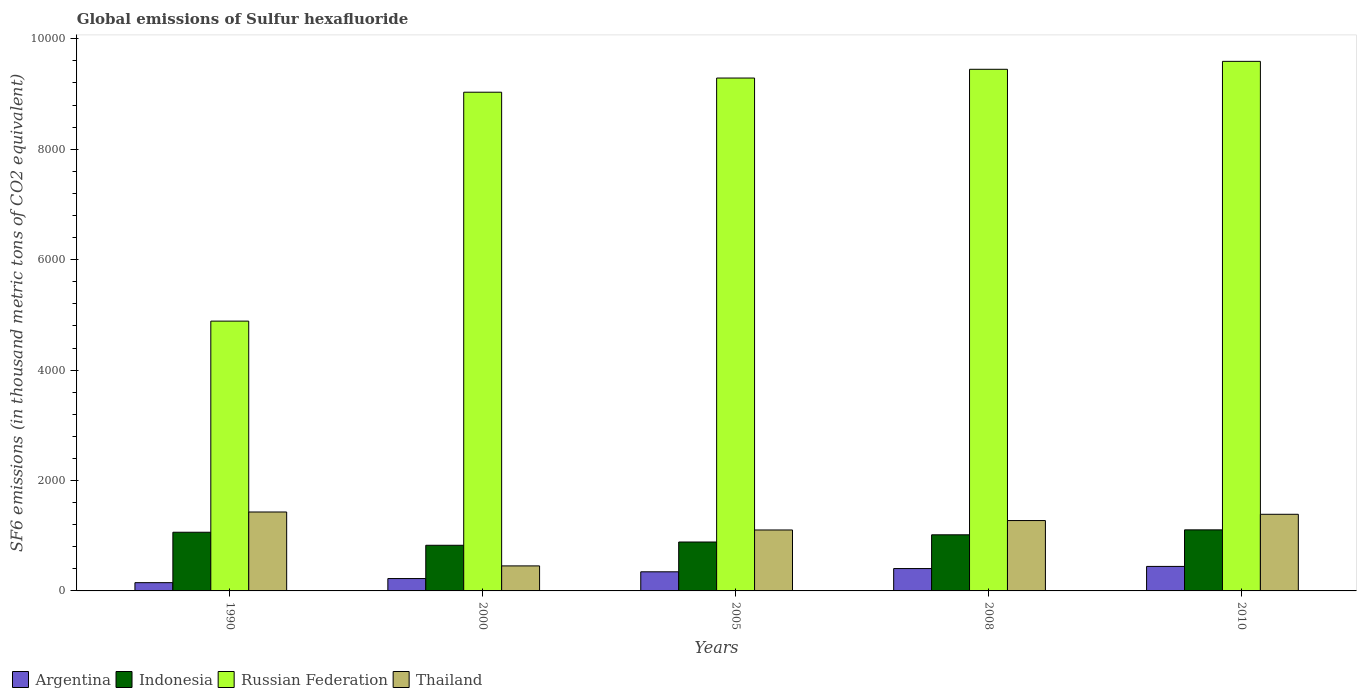How many groups of bars are there?
Your answer should be very brief. 5. Are the number of bars per tick equal to the number of legend labels?
Ensure brevity in your answer.  Yes. Are the number of bars on each tick of the X-axis equal?
Offer a very short reply. Yes. How many bars are there on the 5th tick from the right?
Make the answer very short. 4. What is the label of the 4th group of bars from the left?
Your response must be concise. 2008. In how many cases, is the number of bars for a given year not equal to the number of legend labels?
Offer a terse response. 0. What is the global emissions of Sulfur hexafluoride in Indonesia in 2000?
Your response must be concise. 826.8. Across all years, what is the maximum global emissions of Sulfur hexafluoride in Indonesia?
Give a very brief answer. 1106. Across all years, what is the minimum global emissions of Sulfur hexafluoride in Thailand?
Provide a succinct answer. 453.1. In which year was the global emissions of Sulfur hexafluoride in Thailand maximum?
Your answer should be compact. 1990. In which year was the global emissions of Sulfur hexafluoride in Russian Federation minimum?
Ensure brevity in your answer.  1990. What is the total global emissions of Sulfur hexafluoride in Argentina in the graph?
Make the answer very short. 1568.8. What is the difference between the global emissions of Sulfur hexafluoride in Russian Federation in 1990 and that in 2010?
Your response must be concise. -4705.2. What is the difference between the global emissions of Sulfur hexafluoride in Argentina in 2008 and the global emissions of Sulfur hexafluoride in Russian Federation in 2005?
Make the answer very short. -8884.9. What is the average global emissions of Sulfur hexafluoride in Russian Federation per year?
Your answer should be compact. 8450.02. In the year 2005, what is the difference between the global emissions of Sulfur hexafluoride in Argentina and global emissions of Sulfur hexafluoride in Indonesia?
Ensure brevity in your answer.  -539.9. What is the ratio of the global emissions of Sulfur hexafluoride in Russian Federation in 1990 to that in 2008?
Offer a very short reply. 0.52. Is the difference between the global emissions of Sulfur hexafluoride in Argentina in 1990 and 2000 greater than the difference between the global emissions of Sulfur hexafluoride in Indonesia in 1990 and 2000?
Ensure brevity in your answer.  No. What is the difference between the highest and the second highest global emissions of Sulfur hexafluoride in Thailand?
Your answer should be compact. 41.5. What is the difference between the highest and the lowest global emissions of Sulfur hexafluoride in Indonesia?
Offer a terse response. 279.2. Is the sum of the global emissions of Sulfur hexafluoride in Russian Federation in 1990 and 2010 greater than the maximum global emissions of Sulfur hexafluoride in Indonesia across all years?
Provide a short and direct response. Yes. Is it the case that in every year, the sum of the global emissions of Sulfur hexafluoride in Russian Federation and global emissions of Sulfur hexafluoride in Thailand is greater than the global emissions of Sulfur hexafluoride in Argentina?
Offer a terse response. Yes. How many bars are there?
Provide a succinct answer. 20. How many years are there in the graph?
Ensure brevity in your answer.  5. What is the difference between two consecutive major ticks on the Y-axis?
Provide a short and direct response. 2000. Where does the legend appear in the graph?
Your answer should be compact. Bottom left. How many legend labels are there?
Your response must be concise. 4. How are the legend labels stacked?
Ensure brevity in your answer.  Horizontal. What is the title of the graph?
Provide a succinct answer. Global emissions of Sulfur hexafluoride. Does "Korea (Democratic)" appear as one of the legend labels in the graph?
Your answer should be compact. No. What is the label or title of the X-axis?
Offer a terse response. Years. What is the label or title of the Y-axis?
Your response must be concise. SF6 emissions (in thousand metric tons of CO2 equivalent). What is the SF6 emissions (in thousand metric tons of CO2 equivalent) in Argentina in 1990?
Your response must be concise. 149.6. What is the SF6 emissions (in thousand metric tons of CO2 equivalent) in Indonesia in 1990?
Offer a terse response. 1062.8. What is the SF6 emissions (in thousand metric tons of CO2 equivalent) of Russian Federation in 1990?
Offer a terse response. 4886.8. What is the SF6 emissions (in thousand metric tons of CO2 equivalent) of Thailand in 1990?
Provide a succinct answer. 1429.5. What is the SF6 emissions (in thousand metric tons of CO2 equivalent) in Argentina in 2000?
Provide a short and direct response. 224. What is the SF6 emissions (in thousand metric tons of CO2 equivalent) of Indonesia in 2000?
Give a very brief answer. 826.8. What is the SF6 emissions (in thousand metric tons of CO2 equivalent) of Russian Federation in 2000?
Your answer should be very brief. 9033.2. What is the SF6 emissions (in thousand metric tons of CO2 equivalent) of Thailand in 2000?
Provide a succinct answer. 453.1. What is the SF6 emissions (in thousand metric tons of CO2 equivalent) in Argentina in 2005?
Provide a succinct answer. 346.2. What is the SF6 emissions (in thousand metric tons of CO2 equivalent) of Indonesia in 2005?
Your answer should be very brief. 886.1. What is the SF6 emissions (in thousand metric tons of CO2 equivalent) in Russian Federation in 2005?
Make the answer very short. 9289.9. What is the SF6 emissions (in thousand metric tons of CO2 equivalent) in Thailand in 2005?
Your response must be concise. 1103.9. What is the SF6 emissions (in thousand metric tons of CO2 equivalent) of Argentina in 2008?
Ensure brevity in your answer.  405. What is the SF6 emissions (in thousand metric tons of CO2 equivalent) of Indonesia in 2008?
Give a very brief answer. 1016.4. What is the SF6 emissions (in thousand metric tons of CO2 equivalent) in Russian Federation in 2008?
Your answer should be compact. 9448.2. What is the SF6 emissions (in thousand metric tons of CO2 equivalent) in Thailand in 2008?
Your answer should be compact. 1274.5. What is the SF6 emissions (in thousand metric tons of CO2 equivalent) of Argentina in 2010?
Your response must be concise. 444. What is the SF6 emissions (in thousand metric tons of CO2 equivalent) of Indonesia in 2010?
Make the answer very short. 1106. What is the SF6 emissions (in thousand metric tons of CO2 equivalent) in Russian Federation in 2010?
Offer a terse response. 9592. What is the SF6 emissions (in thousand metric tons of CO2 equivalent) of Thailand in 2010?
Your answer should be compact. 1388. Across all years, what is the maximum SF6 emissions (in thousand metric tons of CO2 equivalent) in Argentina?
Your answer should be very brief. 444. Across all years, what is the maximum SF6 emissions (in thousand metric tons of CO2 equivalent) of Indonesia?
Provide a short and direct response. 1106. Across all years, what is the maximum SF6 emissions (in thousand metric tons of CO2 equivalent) in Russian Federation?
Your response must be concise. 9592. Across all years, what is the maximum SF6 emissions (in thousand metric tons of CO2 equivalent) of Thailand?
Give a very brief answer. 1429.5. Across all years, what is the minimum SF6 emissions (in thousand metric tons of CO2 equivalent) in Argentina?
Keep it short and to the point. 149.6. Across all years, what is the minimum SF6 emissions (in thousand metric tons of CO2 equivalent) in Indonesia?
Provide a short and direct response. 826.8. Across all years, what is the minimum SF6 emissions (in thousand metric tons of CO2 equivalent) in Russian Federation?
Make the answer very short. 4886.8. Across all years, what is the minimum SF6 emissions (in thousand metric tons of CO2 equivalent) of Thailand?
Make the answer very short. 453.1. What is the total SF6 emissions (in thousand metric tons of CO2 equivalent) of Argentina in the graph?
Offer a terse response. 1568.8. What is the total SF6 emissions (in thousand metric tons of CO2 equivalent) of Indonesia in the graph?
Your answer should be compact. 4898.1. What is the total SF6 emissions (in thousand metric tons of CO2 equivalent) in Russian Federation in the graph?
Provide a short and direct response. 4.23e+04. What is the total SF6 emissions (in thousand metric tons of CO2 equivalent) in Thailand in the graph?
Give a very brief answer. 5649. What is the difference between the SF6 emissions (in thousand metric tons of CO2 equivalent) of Argentina in 1990 and that in 2000?
Give a very brief answer. -74.4. What is the difference between the SF6 emissions (in thousand metric tons of CO2 equivalent) of Indonesia in 1990 and that in 2000?
Ensure brevity in your answer.  236. What is the difference between the SF6 emissions (in thousand metric tons of CO2 equivalent) in Russian Federation in 1990 and that in 2000?
Provide a short and direct response. -4146.4. What is the difference between the SF6 emissions (in thousand metric tons of CO2 equivalent) in Thailand in 1990 and that in 2000?
Provide a short and direct response. 976.4. What is the difference between the SF6 emissions (in thousand metric tons of CO2 equivalent) of Argentina in 1990 and that in 2005?
Ensure brevity in your answer.  -196.6. What is the difference between the SF6 emissions (in thousand metric tons of CO2 equivalent) of Indonesia in 1990 and that in 2005?
Provide a succinct answer. 176.7. What is the difference between the SF6 emissions (in thousand metric tons of CO2 equivalent) of Russian Federation in 1990 and that in 2005?
Provide a succinct answer. -4403.1. What is the difference between the SF6 emissions (in thousand metric tons of CO2 equivalent) in Thailand in 1990 and that in 2005?
Provide a short and direct response. 325.6. What is the difference between the SF6 emissions (in thousand metric tons of CO2 equivalent) of Argentina in 1990 and that in 2008?
Give a very brief answer. -255.4. What is the difference between the SF6 emissions (in thousand metric tons of CO2 equivalent) of Indonesia in 1990 and that in 2008?
Your answer should be very brief. 46.4. What is the difference between the SF6 emissions (in thousand metric tons of CO2 equivalent) of Russian Federation in 1990 and that in 2008?
Your answer should be compact. -4561.4. What is the difference between the SF6 emissions (in thousand metric tons of CO2 equivalent) of Thailand in 1990 and that in 2008?
Your answer should be very brief. 155. What is the difference between the SF6 emissions (in thousand metric tons of CO2 equivalent) of Argentina in 1990 and that in 2010?
Offer a terse response. -294.4. What is the difference between the SF6 emissions (in thousand metric tons of CO2 equivalent) in Indonesia in 1990 and that in 2010?
Provide a short and direct response. -43.2. What is the difference between the SF6 emissions (in thousand metric tons of CO2 equivalent) in Russian Federation in 1990 and that in 2010?
Provide a short and direct response. -4705.2. What is the difference between the SF6 emissions (in thousand metric tons of CO2 equivalent) in Thailand in 1990 and that in 2010?
Your answer should be compact. 41.5. What is the difference between the SF6 emissions (in thousand metric tons of CO2 equivalent) of Argentina in 2000 and that in 2005?
Your answer should be compact. -122.2. What is the difference between the SF6 emissions (in thousand metric tons of CO2 equivalent) in Indonesia in 2000 and that in 2005?
Give a very brief answer. -59.3. What is the difference between the SF6 emissions (in thousand metric tons of CO2 equivalent) of Russian Federation in 2000 and that in 2005?
Offer a very short reply. -256.7. What is the difference between the SF6 emissions (in thousand metric tons of CO2 equivalent) of Thailand in 2000 and that in 2005?
Your answer should be very brief. -650.8. What is the difference between the SF6 emissions (in thousand metric tons of CO2 equivalent) of Argentina in 2000 and that in 2008?
Make the answer very short. -181. What is the difference between the SF6 emissions (in thousand metric tons of CO2 equivalent) in Indonesia in 2000 and that in 2008?
Make the answer very short. -189.6. What is the difference between the SF6 emissions (in thousand metric tons of CO2 equivalent) of Russian Federation in 2000 and that in 2008?
Make the answer very short. -415. What is the difference between the SF6 emissions (in thousand metric tons of CO2 equivalent) in Thailand in 2000 and that in 2008?
Offer a terse response. -821.4. What is the difference between the SF6 emissions (in thousand metric tons of CO2 equivalent) in Argentina in 2000 and that in 2010?
Offer a terse response. -220. What is the difference between the SF6 emissions (in thousand metric tons of CO2 equivalent) of Indonesia in 2000 and that in 2010?
Provide a succinct answer. -279.2. What is the difference between the SF6 emissions (in thousand metric tons of CO2 equivalent) of Russian Federation in 2000 and that in 2010?
Give a very brief answer. -558.8. What is the difference between the SF6 emissions (in thousand metric tons of CO2 equivalent) of Thailand in 2000 and that in 2010?
Keep it short and to the point. -934.9. What is the difference between the SF6 emissions (in thousand metric tons of CO2 equivalent) in Argentina in 2005 and that in 2008?
Make the answer very short. -58.8. What is the difference between the SF6 emissions (in thousand metric tons of CO2 equivalent) of Indonesia in 2005 and that in 2008?
Provide a short and direct response. -130.3. What is the difference between the SF6 emissions (in thousand metric tons of CO2 equivalent) in Russian Federation in 2005 and that in 2008?
Provide a succinct answer. -158.3. What is the difference between the SF6 emissions (in thousand metric tons of CO2 equivalent) in Thailand in 2005 and that in 2008?
Make the answer very short. -170.6. What is the difference between the SF6 emissions (in thousand metric tons of CO2 equivalent) of Argentina in 2005 and that in 2010?
Keep it short and to the point. -97.8. What is the difference between the SF6 emissions (in thousand metric tons of CO2 equivalent) of Indonesia in 2005 and that in 2010?
Your answer should be compact. -219.9. What is the difference between the SF6 emissions (in thousand metric tons of CO2 equivalent) in Russian Federation in 2005 and that in 2010?
Your answer should be very brief. -302.1. What is the difference between the SF6 emissions (in thousand metric tons of CO2 equivalent) of Thailand in 2005 and that in 2010?
Make the answer very short. -284.1. What is the difference between the SF6 emissions (in thousand metric tons of CO2 equivalent) in Argentina in 2008 and that in 2010?
Provide a short and direct response. -39. What is the difference between the SF6 emissions (in thousand metric tons of CO2 equivalent) of Indonesia in 2008 and that in 2010?
Your answer should be very brief. -89.6. What is the difference between the SF6 emissions (in thousand metric tons of CO2 equivalent) in Russian Federation in 2008 and that in 2010?
Your answer should be very brief. -143.8. What is the difference between the SF6 emissions (in thousand metric tons of CO2 equivalent) of Thailand in 2008 and that in 2010?
Offer a very short reply. -113.5. What is the difference between the SF6 emissions (in thousand metric tons of CO2 equivalent) in Argentina in 1990 and the SF6 emissions (in thousand metric tons of CO2 equivalent) in Indonesia in 2000?
Offer a very short reply. -677.2. What is the difference between the SF6 emissions (in thousand metric tons of CO2 equivalent) in Argentina in 1990 and the SF6 emissions (in thousand metric tons of CO2 equivalent) in Russian Federation in 2000?
Make the answer very short. -8883.6. What is the difference between the SF6 emissions (in thousand metric tons of CO2 equivalent) of Argentina in 1990 and the SF6 emissions (in thousand metric tons of CO2 equivalent) of Thailand in 2000?
Keep it short and to the point. -303.5. What is the difference between the SF6 emissions (in thousand metric tons of CO2 equivalent) in Indonesia in 1990 and the SF6 emissions (in thousand metric tons of CO2 equivalent) in Russian Federation in 2000?
Offer a terse response. -7970.4. What is the difference between the SF6 emissions (in thousand metric tons of CO2 equivalent) in Indonesia in 1990 and the SF6 emissions (in thousand metric tons of CO2 equivalent) in Thailand in 2000?
Your answer should be compact. 609.7. What is the difference between the SF6 emissions (in thousand metric tons of CO2 equivalent) in Russian Federation in 1990 and the SF6 emissions (in thousand metric tons of CO2 equivalent) in Thailand in 2000?
Provide a short and direct response. 4433.7. What is the difference between the SF6 emissions (in thousand metric tons of CO2 equivalent) of Argentina in 1990 and the SF6 emissions (in thousand metric tons of CO2 equivalent) of Indonesia in 2005?
Keep it short and to the point. -736.5. What is the difference between the SF6 emissions (in thousand metric tons of CO2 equivalent) in Argentina in 1990 and the SF6 emissions (in thousand metric tons of CO2 equivalent) in Russian Federation in 2005?
Offer a very short reply. -9140.3. What is the difference between the SF6 emissions (in thousand metric tons of CO2 equivalent) of Argentina in 1990 and the SF6 emissions (in thousand metric tons of CO2 equivalent) of Thailand in 2005?
Make the answer very short. -954.3. What is the difference between the SF6 emissions (in thousand metric tons of CO2 equivalent) in Indonesia in 1990 and the SF6 emissions (in thousand metric tons of CO2 equivalent) in Russian Federation in 2005?
Your response must be concise. -8227.1. What is the difference between the SF6 emissions (in thousand metric tons of CO2 equivalent) of Indonesia in 1990 and the SF6 emissions (in thousand metric tons of CO2 equivalent) of Thailand in 2005?
Provide a succinct answer. -41.1. What is the difference between the SF6 emissions (in thousand metric tons of CO2 equivalent) in Russian Federation in 1990 and the SF6 emissions (in thousand metric tons of CO2 equivalent) in Thailand in 2005?
Keep it short and to the point. 3782.9. What is the difference between the SF6 emissions (in thousand metric tons of CO2 equivalent) of Argentina in 1990 and the SF6 emissions (in thousand metric tons of CO2 equivalent) of Indonesia in 2008?
Offer a terse response. -866.8. What is the difference between the SF6 emissions (in thousand metric tons of CO2 equivalent) in Argentina in 1990 and the SF6 emissions (in thousand metric tons of CO2 equivalent) in Russian Federation in 2008?
Provide a short and direct response. -9298.6. What is the difference between the SF6 emissions (in thousand metric tons of CO2 equivalent) in Argentina in 1990 and the SF6 emissions (in thousand metric tons of CO2 equivalent) in Thailand in 2008?
Make the answer very short. -1124.9. What is the difference between the SF6 emissions (in thousand metric tons of CO2 equivalent) of Indonesia in 1990 and the SF6 emissions (in thousand metric tons of CO2 equivalent) of Russian Federation in 2008?
Provide a succinct answer. -8385.4. What is the difference between the SF6 emissions (in thousand metric tons of CO2 equivalent) in Indonesia in 1990 and the SF6 emissions (in thousand metric tons of CO2 equivalent) in Thailand in 2008?
Ensure brevity in your answer.  -211.7. What is the difference between the SF6 emissions (in thousand metric tons of CO2 equivalent) in Russian Federation in 1990 and the SF6 emissions (in thousand metric tons of CO2 equivalent) in Thailand in 2008?
Offer a very short reply. 3612.3. What is the difference between the SF6 emissions (in thousand metric tons of CO2 equivalent) in Argentina in 1990 and the SF6 emissions (in thousand metric tons of CO2 equivalent) in Indonesia in 2010?
Offer a very short reply. -956.4. What is the difference between the SF6 emissions (in thousand metric tons of CO2 equivalent) of Argentina in 1990 and the SF6 emissions (in thousand metric tons of CO2 equivalent) of Russian Federation in 2010?
Provide a succinct answer. -9442.4. What is the difference between the SF6 emissions (in thousand metric tons of CO2 equivalent) of Argentina in 1990 and the SF6 emissions (in thousand metric tons of CO2 equivalent) of Thailand in 2010?
Offer a very short reply. -1238.4. What is the difference between the SF6 emissions (in thousand metric tons of CO2 equivalent) of Indonesia in 1990 and the SF6 emissions (in thousand metric tons of CO2 equivalent) of Russian Federation in 2010?
Offer a terse response. -8529.2. What is the difference between the SF6 emissions (in thousand metric tons of CO2 equivalent) in Indonesia in 1990 and the SF6 emissions (in thousand metric tons of CO2 equivalent) in Thailand in 2010?
Ensure brevity in your answer.  -325.2. What is the difference between the SF6 emissions (in thousand metric tons of CO2 equivalent) in Russian Federation in 1990 and the SF6 emissions (in thousand metric tons of CO2 equivalent) in Thailand in 2010?
Provide a short and direct response. 3498.8. What is the difference between the SF6 emissions (in thousand metric tons of CO2 equivalent) in Argentina in 2000 and the SF6 emissions (in thousand metric tons of CO2 equivalent) in Indonesia in 2005?
Your answer should be compact. -662.1. What is the difference between the SF6 emissions (in thousand metric tons of CO2 equivalent) of Argentina in 2000 and the SF6 emissions (in thousand metric tons of CO2 equivalent) of Russian Federation in 2005?
Your answer should be very brief. -9065.9. What is the difference between the SF6 emissions (in thousand metric tons of CO2 equivalent) of Argentina in 2000 and the SF6 emissions (in thousand metric tons of CO2 equivalent) of Thailand in 2005?
Offer a very short reply. -879.9. What is the difference between the SF6 emissions (in thousand metric tons of CO2 equivalent) of Indonesia in 2000 and the SF6 emissions (in thousand metric tons of CO2 equivalent) of Russian Federation in 2005?
Ensure brevity in your answer.  -8463.1. What is the difference between the SF6 emissions (in thousand metric tons of CO2 equivalent) of Indonesia in 2000 and the SF6 emissions (in thousand metric tons of CO2 equivalent) of Thailand in 2005?
Offer a terse response. -277.1. What is the difference between the SF6 emissions (in thousand metric tons of CO2 equivalent) in Russian Federation in 2000 and the SF6 emissions (in thousand metric tons of CO2 equivalent) in Thailand in 2005?
Keep it short and to the point. 7929.3. What is the difference between the SF6 emissions (in thousand metric tons of CO2 equivalent) of Argentina in 2000 and the SF6 emissions (in thousand metric tons of CO2 equivalent) of Indonesia in 2008?
Your answer should be compact. -792.4. What is the difference between the SF6 emissions (in thousand metric tons of CO2 equivalent) in Argentina in 2000 and the SF6 emissions (in thousand metric tons of CO2 equivalent) in Russian Federation in 2008?
Provide a short and direct response. -9224.2. What is the difference between the SF6 emissions (in thousand metric tons of CO2 equivalent) in Argentina in 2000 and the SF6 emissions (in thousand metric tons of CO2 equivalent) in Thailand in 2008?
Provide a short and direct response. -1050.5. What is the difference between the SF6 emissions (in thousand metric tons of CO2 equivalent) of Indonesia in 2000 and the SF6 emissions (in thousand metric tons of CO2 equivalent) of Russian Federation in 2008?
Your response must be concise. -8621.4. What is the difference between the SF6 emissions (in thousand metric tons of CO2 equivalent) in Indonesia in 2000 and the SF6 emissions (in thousand metric tons of CO2 equivalent) in Thailand in 2008?
Offer a very short reply. -447.7. What is the difference between the SF6 emissions (in thousand metric tons of CO2 equivalent) of Russian Federation in 2000 and the SF6 emissions (in thousand metric tons of CO2 equivalent) of Thailand in 2008?
Your answer should be compact. 7758.7. What is the difference between the SF6 emissions (in thousand metric tons of CO2 equivalent) of Argentina in 2000 and the SF6 emissions (in thousand metric tons of CO2 equivalent) of Indonesia in 2010?
Make the answer very short. -882. What is the difference between the SF6 emissions (in thousand metric tons of CO2 equivalent) in Argentina in 2000 and the SF6 emissions (in thousand metric tons of CO2 equivalent) in Russian Federation in 2010?
Your answer should be very brief. -9368. What is the difference between the SF6 emissions (in thousand metric tons of CO2 equivalent) of Argentina in 2000 and the SF6 emissions (in thousand metric tons of CO2 equivalent) of Thailand in 2010?
Ensure brevity in your answer.  -1164. What is the difference between the SF6 emissions (in thousand metric tons of CO2 equivalent) of Indonesia in 2000 and the SF6 emissions (in thousand metric tons of CO2 equivalent) of Russian Federation in 2010?
Ensure brevity in your answer.  -8765.2. What is the difference between the SF6 emissions (in thousand metric tons of CO2 equivalent) in Indonesia in 2000 and the SF6 emissions (in thousand metric tons of CO2 equivalent) in Thailand in 2010?
Your answer should be very brief. -561.2. What is the difference between the SF6 emissions (in thousand metric tons of CO2 equivalent) of Russian Federation in 2000 and the SF6 emissions (in thousand metric tons of CO2 equivalent) of Thailand in 2010?
Provide a short and direct response. 7645.2. What is the difference between the SF6 emissions (in thousand metric tons of CO2 equivalent) in Argentina in 2005 and the SF6 emissions (in thousand metric tons of CO2 equivalent) in Indonesia in 2008?
Provide a short and direct response. -670.2. What is the difference between the SF6 emissions (in thousand metric tons of CO2 equivalent) in Argentina in 2005 and the SF6 emissions (in thousand metric tons of CO2 equivalent) in Russian Federation in 2008?
Your answer should be very brief. -9102. What is the difference between the SF6 emissions (in thousand metric tons of CO2 equivalent) of Argentina in 2005 and the SF6 emissions (in thousand metric tons of CO2 equivalent) of Thailand in 2008?
Provide a short and direct response. -928.3. What is the difference between the SF6 emissions (in thousand metric tons of CO2 equivalent) in Indonesia in 2005 and the SF6 emissions (in thousand metric tons of CO2 equivalent) in Russian Federation in 2008?
Your answer should be very brief. -8562.1. What is the difference between the SF6 emissions (in thousand metric tons of CO2 equivalent) in Indonesia in 2005 and the SF6 emissions (in thousand metric tons of CO2 equivalent) in Thailand in 2008?
Give a very brief answer. -388.4. What is the difference between the SF6 emissions (in thousand metric tons of CO2 equivalent) of Russian Federation in 2005 and the SF6 emissions (in thousand metric tons of CO2 equivalent) of Thailand in 2008?
Ensure brevity in your answer.  8015.4. What is the difference between the SF6 emissions (in thousand metric tons of CO2 equivalent) of Argentina in 2005 and the SF6 emissions (in thousand metric tons of CO2 equivalent) of Indonesia in 2010?
Your answer should be very brief. -759.8. What is the difference between the SF6 emissions (in thousand metric tons of CO2 equivalent) in Argentina in 2005 and the SF6 emissions (in thousand metric tons of CO2 equivalent) in Russian Federation in 2010?
Your answer should be very brief. -9245.8. What is the difference between the SF6 emissions (in thousand metric tons of CO2 equivalent) of Argentina in 2005 and the SF6 emissions (in thousand metric tons of CO2 equivalent) of Thailand in 2010?
Ensure brevity in your answer.  -1041.8. What is the difference between the SF6 emissions (in thousand metric tons of CO2 equivalent) of Indonesia in 2005 and the SF6 emissions (in thousand metric tons of CO2 equivalent) of Russian Federation in 2010?
Offer a very short reply. -8705.9. What is the difference between the SF6 emissions (in thousand metric tons of CO2 equivalent) of Indonesia in 2005 and the SF6 emissions (in thousand metric tons of CO2 equivalent) of Thailand in 2010?
Keep it short and to the point. -501.9. What is the difference between the SF6 emissions (in thousand metric tons of CO2 equivalent) in Russian Federation in 2005 and the SF6 emissions (in thousand metric tons of CO2 equivalent) in Thailand in 2010?
Ensure brevity in your answer.  7901.9. What is the difference between the SF6 emissions (in thousand metric tons of CO2 equivalent) of Argentina in 2008 and the SF6 emissions (in thousand metric tons of CO2 equivalent) of Indonesia in 2010?
Your answer should be compact. -701. What is the difference between the SF6 emissions (in thousand metric tons of CO2 equivalent) of Argentina in 2008 and the SF6 emissions (in thousand metric tons of CO2 equivalent) of Russian Federation in 2010?
Keep it short and to the point. -9187. What is the difference between the SF6 emissions (in thousand metric tons of CO2 equivalent) in Argentina in 2008 and the SF6 emissions (in thousand metric tons of CO2 equivalent) in Thailand in 2010?
Make the answer very short. -983. What is the difference between the SF6 emissions (in thousand metric tons of CO2 equivalent) of Indonesia in 2008 and the SF6 emissions (in thousand metric tons of CO2 equivalent) of Russian Federation in 2010?
Provide a short and direct response. -8575.6. What is the difference between the SF6 emissions (in thousand metric tons of CO2 equivalent) in Indonesia in 2008 and the SF6 emissions (in thousand metric tons of CO2 equivalent) in Thailand in 2010?
Offer a very short reply. -371.6. What is the difference between the SF6 emissions (in thousand metric tons of CO2 equivalent) in Russian Federation in 2008 and the SF6 emissions (in thousand metric tons of CO2 equivalent) in Thailand in 2010?
Provide a succinct answer. 8060.2. What is the average SF6 emissions (in thousand metric tons of CO2 equivalent) in Argentina per year?
Your response must be concise. 313.76. What is the average SF6 emissions (in thousand metric tons of CO2 equivalent) in Indonesia per year?
Provide a succinct answer. 979.62. What is the average SF6 emissions (in thousand metric tons of CO2 equivalent) of Russian Federation per year?
Your answer should be very brief. 8450.02. What is the average SF6 emissions (in thousand metric tons of CO2 equivalent) in Thailand per year?
Keep it short and to the point. 1129.8. In the year 1990, what is the difference between the SF6 emissions (in thousand metric tons of CO2 equivalent) in Argentina and SF6 emissions (in thousand metric tons of CO2 equivalent) in Indonesia?
Your answer should be very brief. -913.2. In the year 1990, what is the difference between the SF6 emissions (in thousand metric tons of CO2 equivalent) of Argentina and SF6 emissions (in thousand metric tons of CO2 equivalent) of Russian Federation?
Your response must be concise. -4737.2. In the year 1990, what is the difference between the SF6 emissions (in thousand metric tons of CO2 equivalent) of Argentina and SF6 emissions (in thousand metric tons of CO2 equivalent) of Thailand?
Give a very brief answer. -1279.9. In the year 1990, what is the difference between the SF6 emissions (in thousand metric tons of CO2 equivalent) of Indonesia and SF6 emissions (in thousand metric tons of CO2 equivalent) of Russian Federation?
Your response must be concise. -3824. In the year 1990, what is the difference between the SF6 emissions (in thousand metric tons of CO2 equivalent) in Indonesia and SF6 emissions (in thousand metric tons of CO2 equivalent) in Thailand?
Offer a very short reply. -366.7. In the year 1990, what is the difference between the SF6 emissions (in thousand metric tons of CO2 equivalent) in Russian Federation and SF6 emissions (in thousand metric tons of CO2 equivalent) in Thailand?
Give a very brief answer. 3457.3. In the year 2000, what is the difference between the SF6 emissions (in thousand metric tons of CO2 equivalent) of Argentina and SF6 emissions (in thousand metric tons of CO2 equivalent) of Indonesia?
Your answer should be compact. -602.8. In the year 2000, what is the difference between the SF6 emissions (in thousand metric tons of CO2 equivalent) of Argentina and SF6 emissions (in thousand metric tons of CO2 equivalent) of Russian Federation?
Your answer should be very brief. -8809.2. In the year 2000, what is the difference between the SF6 emissions (in thousand metric tons of CO2 equivalent) of Argentina and SF6 emissions (in thousand metric tons of CO2 equivalent) of Thailand?
Provide a succinct answer. -229.1. In the year 2000, what is the difference between the SF6 emissions (in thousand metric tons of CO2 equivalent) in Indonesia and SF6 emissions (in thousand metric tons of CO2 equivalent) in Russian Federation?
Offer a terse response. -8206.4. In the year 2000, what is the difference between the SF6 emissions (in thousand metric tons of CO2 equivalent) in Indonesia and SF6 emissions (in thousand metric tons of CO2 equivalent) in Thailand?
Keep it short and to the point. 373.7. In the year 2000, what is the difference between the SF6 emissions (in thousand metric tons of CO2 equivalent) in Russian Federation and SF6 emissions (in thousand metric tons of CO2 equivalent) in Thailand?
Your answer should be very brief. 8580.1. In the year 2005, what is the difference between the SF6 emissions (in thousand metric tons of CO2 equivalent) in Argentina and SF6 emissions (in thousand metric tons of CO2 equivalent) in Indonesia?
Your answer should be compact. -539.9. In the year 2005, what is the difference between the SF6 emissions (in thousand metric tons of CO2 equivalent) of Argentina and SF6 emissions (in thousand metric tons of CO2 equivalent) of Russian Federation?
Your response must be concise. -8943.7. In the year 2005, what is the difference between the SF6 emissions (in thousand metric tons of CO2 equivalent) in Argentina and SF6 emissions (in thousand metric tons of CO2 equivalent) in Thailand?
Make the answer very short. -757.7. In the year 2005, what is the difference between the SF6 emissions (in thousand metric tons of CO2 equivalent) of Indonesia and SF6 emissions (in thousand metric tons of CO2 equivalent) of Russian Federation?
Provide a succinct answer. -8403.8. In the year 2005, what is the difference between the SF6 emissions (in thousand metric tons of CO2 equivalent) of Indonesia and SF6 emissions (in thousand metric tons of CO2 equivalent) of Thailand?
Your response must be concise. -217.8. In the year 2005, what is the difference between the SF6 emissions (in thousand metric tons of CO2 equivalent) in Russian Federation and SF6 emissions (in thousand metric tons of CO2 equivalent) in Thailand?
Offer a very short reply. 8186. In the year 2008, what is the difference between the SF6 emissions (in thousand metric tons of CO2 equivalent) of Argentina and SF6 emissions (in thousand metric tons of CO2 equivalent) of Indonesia?
Keep it short and to the point. -611.4. In the year 2008, what is the difference between the SF6 emissions (in thousand metric tons of CO2 equivalent) in Argentina and SF6 emissions (in thousand metric tons of CO2 equivalent) in Russian Federation?
Keep it short and to the point. -9043.2. In the year 2008, what is the difference between the SF6 emissions (in thousand metric tons of CO2 equivalent) of Argentina and SF6 emissions (in thousand metric tons of CO2 equivalent) of Thailand?
Provide a short and direct response. -869.5. In the year 2008, what is the difference between the SF6 emissions (in thousand metric tons of CO2 equivalent) in Indonesia and SF6 emissions (in thousand metric tons of CO2 equivalent) in Russian Federation?
Offer a very short reply. -8431.8. In the year 2008, what is the difference between the SF6 emissions (in thousand metric tons of CO2 equivalent) of Indonesia and SF6 emissions (in thousand metric tons of CO2 equivalent) of Thailand?
Offer a terse response. -258.1. In the year 2008, what is the difference between the SF6 emissions (in thousand metric tons of CO2 equivalent) in Russian Federation and SF6 emissions (in thousand metric tons of CO2 equivalent) in Thailand?
Your response must be concise. 8173.7. In the year 2010, what is the difference between the SF6 emissions (in thousand metric tons of CO2 equivalent) of Argentina and SF6 emissions (in thousand metric tons of CO2 equivalent) of Indonesia?
Offer a very short reply. -662. In the year 2010, what is the difference between the SF6 emissions (in thousand metric tons of CO2 equivalent) in Argentina and SF6 emissions (in thousand metric tons of CO2 equivalent) in Russian Federation?
Give a very brief answer. -9148. In the year 2010, what is the difference between the SF6 emissions (in thousand metric tons of CO2 equivalent) in Argentina and SF6 emissions (in thousand metric tons of CO2 equivalent) in Thailand?
Your response must be concise. -944. In the year 2010, what is the difference between the SF6 emissions (in thousand metric tons of CO2 equivalent) in Indonesia and SF6 emissions (in thousand metric tons of CO2 equivalent) in Russian Federation?
Offer a terse response. -8486. In the year 2010, what is the difference between the SF6 emissions (in thousand metric tons of CO2 equivalent) in Indonesia and SF6 emissions (in thousand metric tons of CO2 equivalent) in Thailand?
Offer a terse response. -282. In the year 2010, what is the difference between the SF6 emissions (in thousand metric tons of CO2 equivalent) in Russian Federation and SF6 emissions (in thousand metric tons of CO2 equivalent) in Thailand?
Offer a terse response. 8204. What is the ratio of the SF6 emissions (in thousand metric tons of CO2 equivalent) of Argentina in 1990 to that in 2000?
Offer a very short reply. 0.67. What is the ratio of the SF6 emissions (in thousand metric tons of CO2 equivalent) in Indonesia in 1990 to that in 2000?
Give a very brief answer. 1.29. What is the ratio of the SF6 emissions (in thousand metric tons of CO2 equivalent) in Russian Federation in 1990 to that in 2000?
Offer a very short reply. 0.54. What is the ratio of the SF6 emissions (in thousand metric tons of CO2 equivalent) of Thailand in 1990 to that in 2000?
Your response must be concise. 3.15. What is the ratio of the SF6 emissions (in thousand metric tons of CO2 equivalent) in Argentina in 1990 to that in 2005?
Your answer should be compact. 0.43. What is the ratio of the SF6 emissions (in thousand metric tons of CO2 equivalent) of Indonesia in 1990 to that in 2005?
Give a very brief answer. 1.2. What is the ratio of the SF6 emissions (in thousand metric tons of CO2 equivalent) in Russian Federation in 1990 to that in 2005?
Keep it short and to the point. 0.53. What is the ratio of the SF6 emissions (in thousand metric tons of CO2 equivalent) of Thailand in 1990 to that in 2005?
Provide a short and direct response. 1.29. What is the ratio of the SF6 emissions (in thousand metric tons of CO2 equivalent) of Argentina in 1990 to that in 2008?
Provide a succinct answer. 0.37. What is the ratio of the SF6 emissions (in thousand metric tons of CO2 equivalent) of Indonesia in 1990 to that in 2008?
Offer a terse response. 1.05. What is the ratio of the SF6 emissions (in thousand metric tons of CO2 equivalent) in Russian Federation in 1990 to that in 2008?
Your answer should be compact. 0.52. What is the ratio of the SF6 emissions (in thousand metric tons of CO2 equivalent) of Thailand in 1990 to that in 2008?
Your response must be concise. 1.12. What is the ratio of the SF6 emissions (in thousand metric tons of CO2 equivalent) of Argentina in 1990 to that in 2010?
Your answer should be compact. 0.34. What is the ratio of the SF6 emissions (in thousand metric tons of CO2 equivalent) of Indonesia in 1990 to that in 2010?
Ensure brevity in your answer.  0.96. What is the ratio of the SF6 emissions (in thousand metric tons of CO2 equivalent) of Russian Federation in 1990 to that in 2010?
Offer a very short reply. 0.51. What is the ratio of the SF6 emissions (in thousand metric tons of CO2 equivalent) in Thailand in 1990 to that in 2010?
Your answer should be very brief. 1.03. What is the ratio of the SF6 emissions (in thousand metric tons of CO2 equivalent) of Argentina in 2000 to that in 2005?
Provide a succinct answer. 0.65. What is the ratio of the SF6 emissions (in thousand metric tons of CO2 equivalent) in Indonesia in 2000 to that in 2005?
Ensure brevity in your answer.  0.93. What is the ratio of the SF6 emissions (in thousand metric tons of CO2 equivalent) in Russian Federation in 2000 to that in 2005?
Your response must be concise. 0.97. What is the ratio of the SF6 emissions (in thousand metric tons of CO2 equivalent) in Thailand in 2000 to that in 2005?
Provide a succinct answer. 0.41. What is the ratio of the SF6 emissions (in thousand metric tons of CO2 equivalent) in Argentina in 2000 to that in 2008?
Provide a short and direct response. 0.55. What is the ratio of the SF6 emissions (in thousand metric tons of CO2 equivalent) in Indonesia in 2000 to that in 2008?
Make the answer very short. 0.81. What is the ratio of the SF6 emissions (in thousand metric tons of CO2 equivalent) of Russian Federation in 2000 to that in 2008?
Give a very brief answer. 0.96. What is the ratio of the SF6 emissions (in thousand metric tons of CO2 equivalent) in Thailand in 2000 to that in 2008?
Offer a terse response. 0.36. What is the ratio of the SF6 emissions (in thousand metric tons of CO2 equivalent) of Argentina in 2000 to that in 2010?
Offer a very short reply. 0.5. What is the ratio of the SF6 emissions (in thousand metric tons of CO2 equivalent) in Indonesia in 2000 to that in 2010?
Your response must be concise. 0.75. What is the ratio of the SF6 emissions (in thousand metric tons of CO2 equivalent) of Russian Federation in 2000 to that in 2010?
Offer a terse response. 0.94. What is the ratio of the SF6 emissions (in thousand metric tons of CO2 equivalent) of Thailand in 2000 to that in 2010?
Your response must be concise. 0.33. What is the ratio of the SF6 emissions (in thousand metric tons of CO2 equivalent) in Argentina in 2005 to that in 2008?
Offer a terse response. 0.85. What is the ratio of the SF6 emissions (in thousand metric tons of CO2 equivalent) in Indonesia in 2005 to that in 2008?
Provide a succinct answer. 0.87. What is the ratio of the SF6 emissions (in thousand metric tons of CO2 equivalent) in Russian Federation in 2005 to that in 2008?
Your response must be concise. 0.98. What is the ratio of the SF6 emissions (in thousand metric tons of CO2 equivalent) of Thailand in 2005 to that in 2008?
Provide a short and direct response. 0.87. What is the ratio of the SF6 emissions (in thousand metric tons of CO2 equivalent) of Argentina in 2005 to that in 2010?
Offer a terse response. 0.78. What is the ratio of the SF6 emissions (in thousand metric tons of CO2 equivalent) in Indonesia in 2005 to that in 2010?
Your response must be concise. 0.8. What is the ratio of the SF6 emissions (in thousand metric tons of CO2 equivalent) of Russian Federation in 2005 to that in 2010?
Provide a short and direct response. 0.97. What is the ratio of the SF6 emissions (in thousand metric tons of CO2 equivalent) of Thailand in 2005 to that in 2010?
Offer a terse response. 0.8. What is the ratio of the SF6 emissions (in thousand metric tons of CO2 equivalent) of Argentina in 2008 to that in 2010?
Keep it short and to the point. 0.91. What is the ratio of the SF6 emissions (in thousand metric tons of CO2 equivalent) in Indonesia in 2008 to that in 2010?
Your answer should be compact. 0.92. What is the ratio of the SF6 emissions (in thousand metric tons of CO2 equivalent) in Russian Federation in 2008 to that in 2010?
Your response must be concise. 0.98. What is the ratio of the SF6 emissions (in thousand metric tons of CO2 equivalent) of Thailand in 2008 to that in 2010?
Offer a terse response. 0.92. What is the difference between the highest and the second highest SF6 emissions (in thousand metric tons of CO2 equivalent) in Argentina?
Provide a succinct answer. 39. What is the difference between the highest and the second highest SF6 emissions (in thousand metric tons of CO2 equivalent) of Indonesia?
Ensure brevity in your answer.  43.2. What is the difference between the highest and the second highest SF6 emissions (in thousand metric tons of CO2 equivalent) in Russian Federation?
Offer a terse response. 143.8. What is the difference between the highest and the second highest SF6 emissions (in thousand metric tons of CO2 equivalent) of Thailand?
Ensure brevity in your answer.  41.5. What is the difference between the highest and the lowest SF6 emissions (in thousand metric tons of CO2 equivalent) in Argentina?
Provide a short and direct response. 294.4. What is the difference between the highest and the lowest SF6 emissions (in thousand metric tons of CO2 equivalent) in Indonesia?
Provide a short and direct response. 279.2. What is the difference between the highest and the lowest SF6 emissions (in thousand metric tons of CO2 equivalent) of Russian Federation?
Provide a succinct answer. 4705.2. What is the difference between the highest and the lowest SF6 emissions (in thousand metric tons of CO2 equivalent) in Thailand?
Your answer should be very brief. 976.4. 